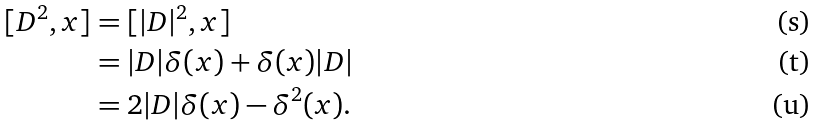<formula> <loc_0><loc_0><loc_500><loc_500>[ D ^ { 2 } , x ] & = [ | D | ^ { 2 } , x ] \\ & = | D | \delta ( x ) + \delta ( x ) | D | \\ & = 2 | D | \delta ( x ) - \delta ^ { 2 } ( x ) .</formula> 